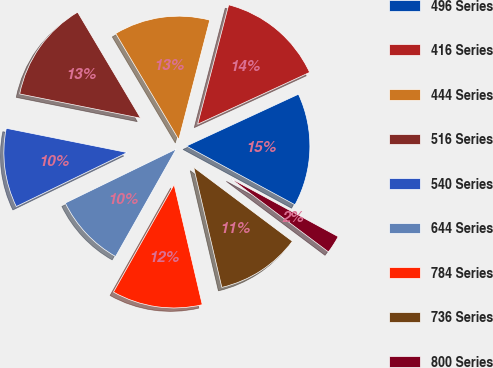Convert chart to OTSL. <chart><loc_0><loc_0><loc_500><loc_500><pie_chart><fcel>496 Series<fcel>416 Series<fcel>444 Series<fcel>516 Series<fcel>540 Series<fcel>644 Series<fcel>784 Series<fcel>736 Series<fcel>800 Series<nl><fcel>14.8%<fcel>14.06%<fcel>12.58%<fcel>13.32%<fcel>10.36%<fcel>9.62%<fcel>11.84%<fcel>11.1%<fcel>2.34%<nl></chart> 